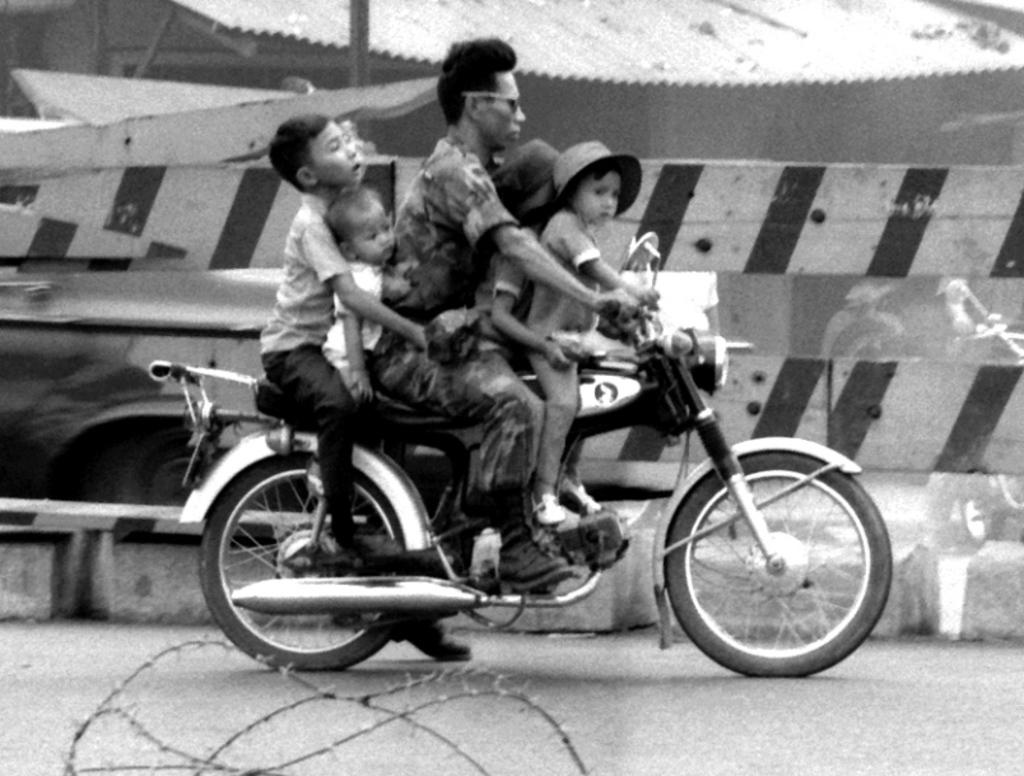How many people are the number of people in the image? There are five persons in the image. What are the people doing in the image? The persons are sitting on a bike. What is the color scheme of the image? The image is in black and white. What can be seen in the background of the image? There is a road and a fence in the image. What type of bells can be heard ringing in the image? There are no bells present in the image, and therefore no sound can be heard. 